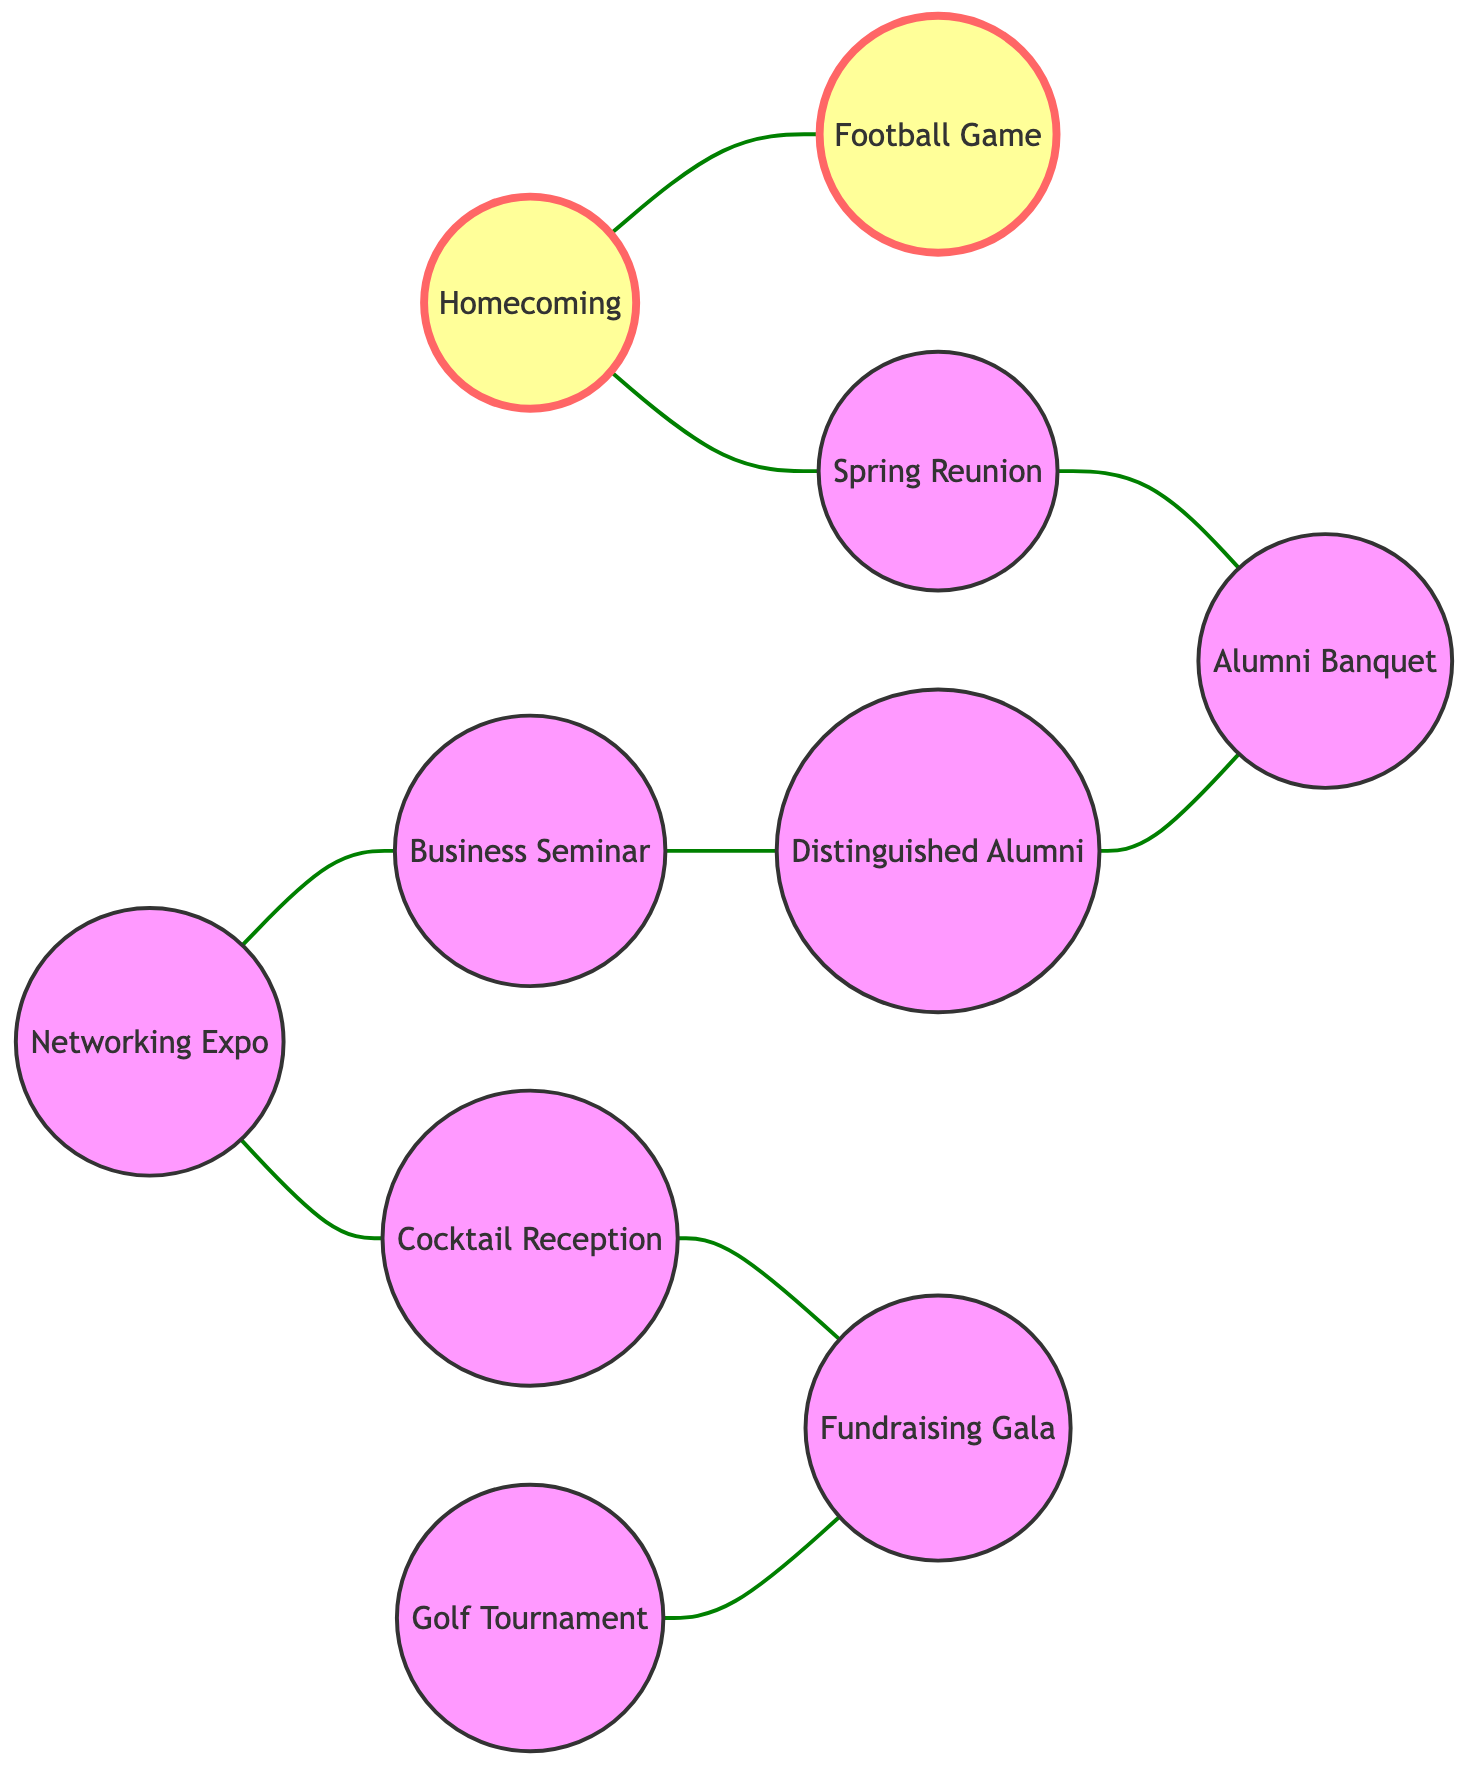What are the total number of nodes in the diagram? The diagram lists 10 unique events or gatherings as nodes: Homecoming, Spring Reunion, Networking Expo, Distinguished Alumni Awards, Football Game, Alumni Banquet, Business Seminar, Cocktail Reception, Golf Tournament, and Fundraising Gala. Counting these gives us a total of 10 nodes.
Answer: 10 Which event is related to both Homecoming and Spring Reunion? The question is asking about the node that connects to both Homecoming and Spring Reunion in the graph. By reviewing the edges, Homecoming connects directly to Football Game and Spring Reunion connects to Alumni Banquet, thus no single event is shared between both nodes. Therefore, none is related.
Answer: None How many events are directly related to the Networking Expo? The Networking Expo has two direct connections: one to the Business Seminar and the other to the Cocktail Reception. Counting these edges gives a total of 2 events related to Networking Expo.
Answer: 2 What is connected to the Fundraising Gala? The Fundraising Gala is directly related to two events: Golf Tournament and Cocktail Reception. Both of these events have an edge connecting to Fundraising Gala. Thus, the answer includes both connections.
Answer: Golf Tournament, Cocktail Reception Which event has the most direct connections? To find this, we can examine each node's edges. Homecoming has connections to Football Game and Spring Reunion (2 connections). Spring Reunion connects to Alumni Banquet (1 connection). Networking Expo connects to Business Seminar and Cocktail Reception (2 connections). Distinguished Alumni connects to Alumni Banquet (1 connection). Football Game connects to Homecoming (1 connection). Alumni Banquet connects to Spring Reunion and Distinguished Alumni (2 connections). Business Seminar connects to Distinguished Alumni (1 connection). Cocktail Reception connects to Networking Expo and Fundraising Gala (2 connections). Golf Tournament connects to Fundraising Gala (1 connection). Hence, the events with the most connections (3) are Alumni Banquet and Networking Expo.
Answer: Alumni Banquet, Networking Expo What is the relationship between Distinguished Alumni Awards and Alumni Banquet? The relationship can be found by checking the connection in the edges. The edge between Distinguished Alumni and Alumni Banquet indicates a direct relationship, showing that these two events are connected.
Answer: Connected 